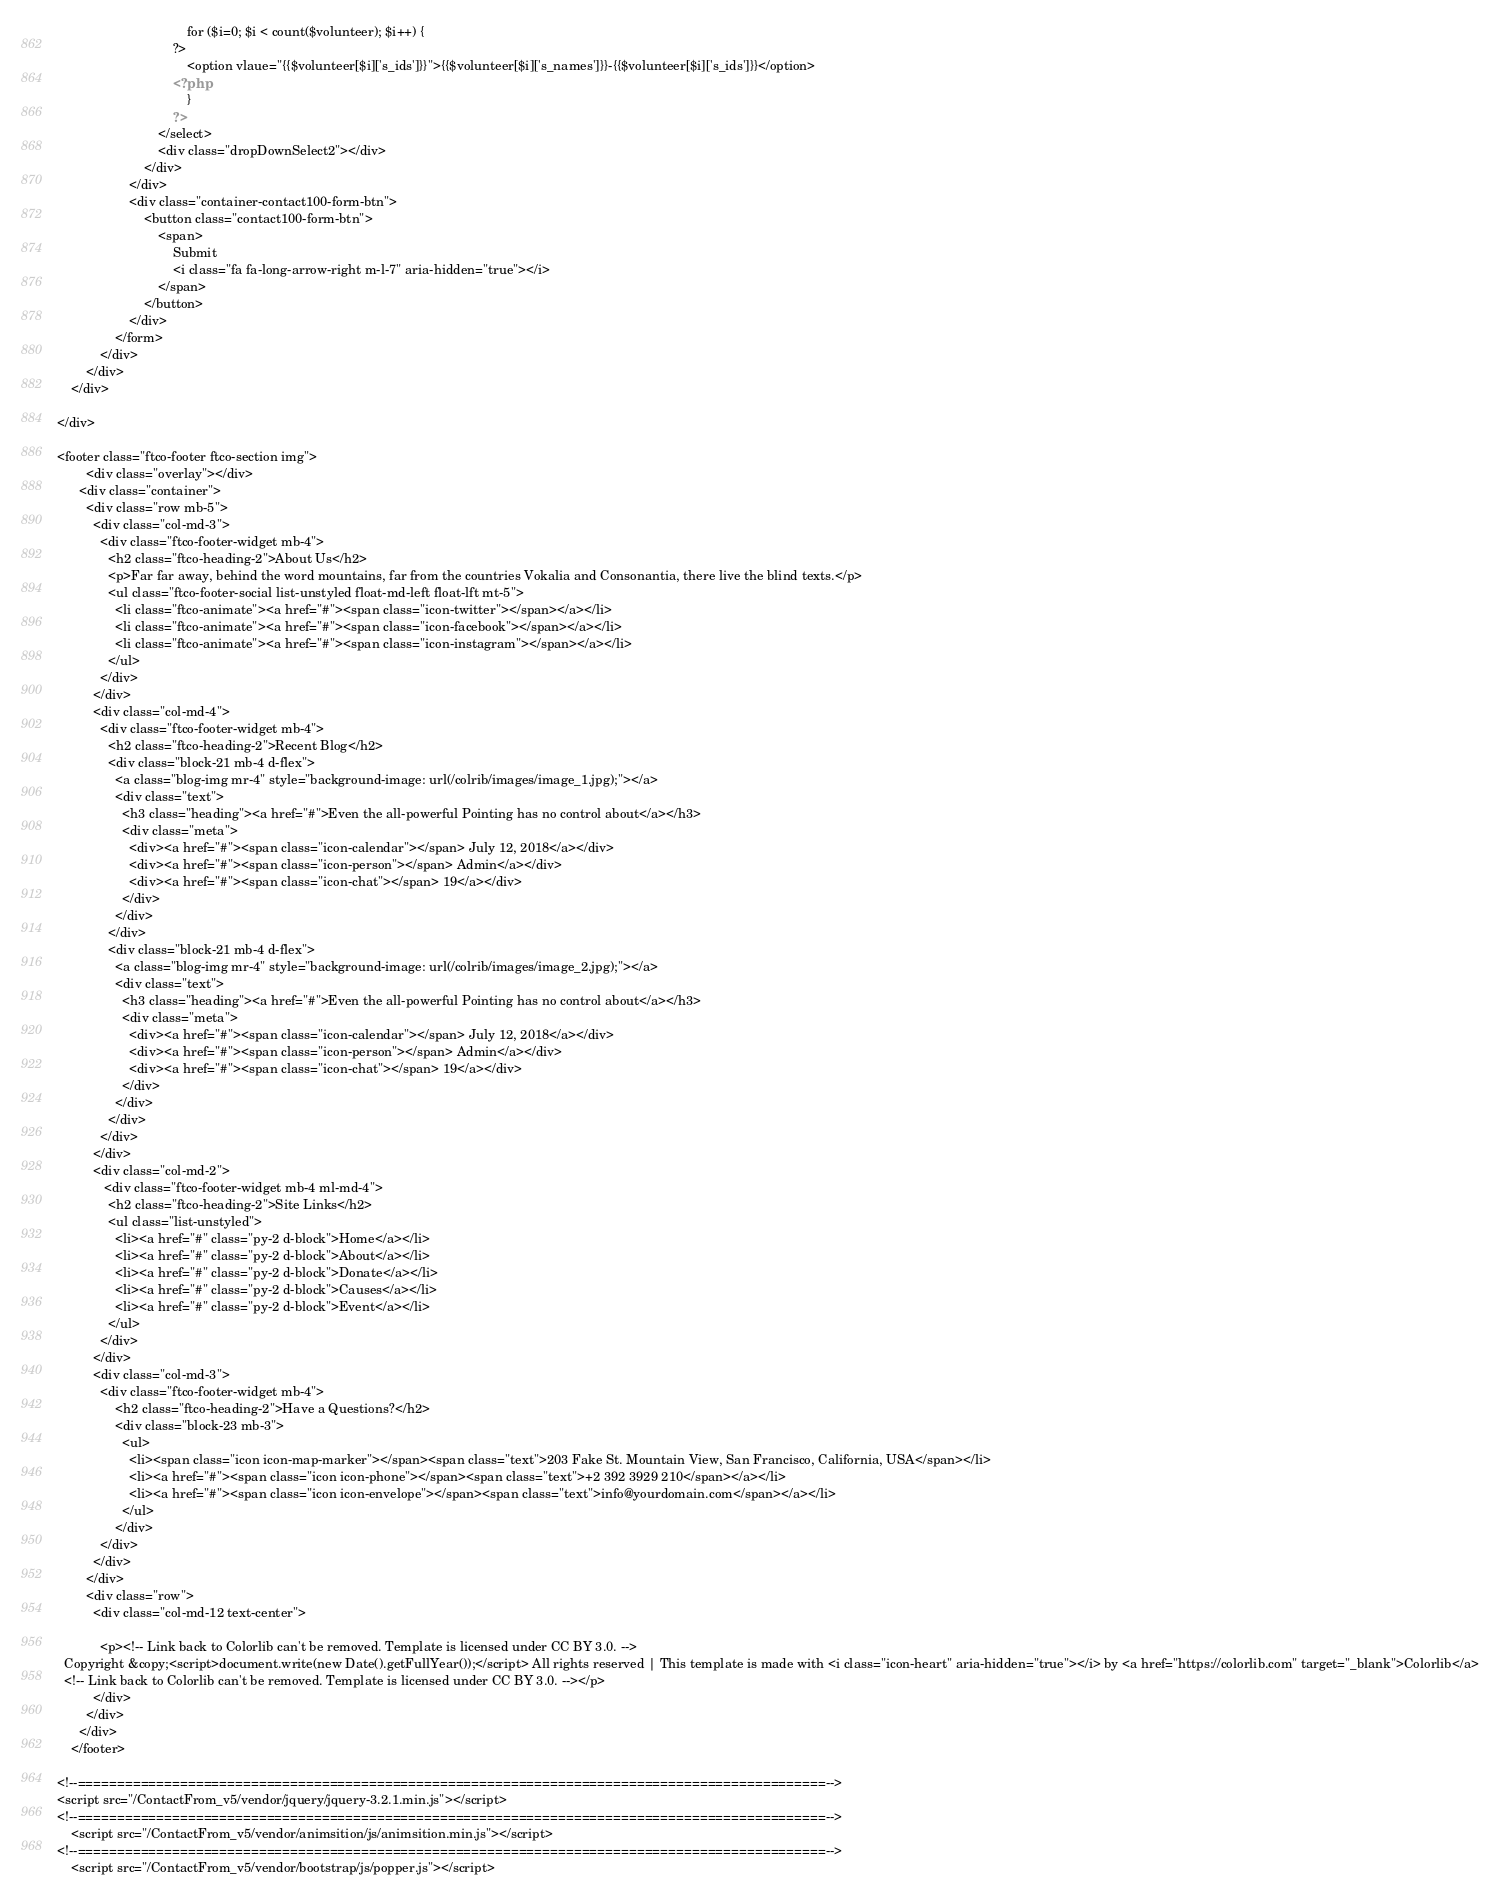<code> <loc_0><loc_0><loc_500><loc_500><_PHP_>									for ($i=0; $i < count($volunteer); $i++) { 
								?>
									<option vlaue="{{$volunteer[$i]['s_ids']}}">{{$volunteer[$i]['s_names']}}-{{$volunteer[$i]['s_ids']}}</option>
								<?php
									}
								?>
							</select>							
							<div class="dropDownSelect2"></div>
						</div>
					</div>
					<div class="container-contact100-form-btn">
						<button class="contact100-form-btn">
							<span>
								Submit
								<i class="fa fa-long-arrow-right m-l-7" aria-hidden="true"></i>
							</span>
						</button>
					</div>
				</form>
			</div>
		</div>
	</div>
	
</div>

<footer class="ftco-footer ftco-section img">
    	<div class="overlay"></div>
      <div class="container">
        <div class="row mb-5">
          <div class="col-md-3">
            <div class="ftco-footer-widget mb-4">
              <h2 class="ftco-heading-2">About Us</h2>
              <p>Far far away, behind the word mountains, far from the countries Vokalia and Consonantia, there live the blind texts.</p>
              <ul class="ftco-footer-social list-unstyled float-md-left float-lft mt-5">
                <li class="ftco-animate"><a href="#"><span class="icon-twitter"></span></a></li>
                <li class="ftco-animate"><a href="#"><span class="icon-facebook"></span></a></li>
                <li class="ftco-animate"><a href="#"><span class="icon-instagram"></span></a></li>
              </ul>
            </div>
          </div>
          <div class="col-md-4">
            <div class="ftco-footer-widget mb-4">
              <h2 class="ftco-heading-2">Recent Blog</h2>
              <div class="block-21 mb-4 d-flex">
                <a class="blog-img mr-4" style="background-image: url(/colrib/images/image_1.jpg);"></a>
                <div class="text">
                  <h3 class="heading"><a href="#">Even the all-powerful Pointing has no control about</a></h3>
                  <div class="meta">
                    <div><a href="#"><span class="icon-calendar"></span> July 12, 2018</a></div>
                    <div><a href="#"><span class="icon-person"></span> Admin</a></div>
                    <div><a href="#"><span class="icon-chat"></span> 19</a></div>
                  </div>
                </div>
              </div>
              <div class="block-21 mb-4 d-flex">
                <a class="blog-img mr-4" style="background-image: url(/colrib/images/image_2.jpg);"></a>
                <div class="text">
                  <h3 class="heading"><a href="#">Even the all-powerful Pointing has no control about</a></h3>
                  <div class="meta">
                    <div><a href="#"><span class="icon-calendar"></span> July 12, 2018</a></div>
                    <div><a href="#"><span class="icon-person"></span> Admin</a></div>
                    <div><a href="#"><span class="icon-chat"></span> 19</a></div>
                  </div>
                </div>
              </div>
            </div>
          </div>
          <div class="col-md-2">
             <div class="ftco-footer-widget mb-4 ml-md-4">
              <h2 class="ftco-heading-2">Site Links</h2>
              <ul class="list-unstyled">
                <li><a href="#" class="py-2 d-block">Home</a></li>
                <li><a href="#" class="py-2 d-block">About</a></li>
                <li><a href="#" class="py-2 d-block">Donate</a></li>
                <li><a href="#" class="py-2 d-block">Causes</a></li>
                <li><a href="#" class="py-2 d-block">Event</a></li>
              </ul>
            </div>
          </div>
          <div class="col-md-3">
            <div class="ftco-footer-widget mb-4">
            	<h2 class="ftco-heading-2">Have a Questions?</h2>
            	<div class="block-23 mb-3">
	              <ul>
	                <li><span class="icon icon-map-marker"></span><span class="text">203 Fake St. Mountain View, San Francisco, California, USA</span></li>
	                <li><a href="#"><span class="icon icon-phone"></span><span class="text">+2 392 3929 210</span></a></li>
	                <li><a href="#"><span class="icon icon-envelope"></span><span class="text">info@yourdomain.com</span></a></li>
	              </ul>
	            </div>
            </div>
          </div>
        </div>
        <div class="row">
          <div class="col-md-12 text-center">

            <p><!-- Link back to Colorlib can't be removed. Template is licensed under CC BY 3.0. -->
  Copyright &copy;<script>document.write(new Date().getFullYear());</script> All rights reserved | This template is made with <i class="icon-heart" aria-hidden="true"></i> by <a href="https://colorlib.com" target="_blank">Colorlib</a>
  <!-- Link back to Colorlib can't be removed. Template is licensed under CC BY 3.0. --></p>
          </div>
        </div>
      </div>
    </footer>

<!--===============================================================================================-->
<script src="/ContactFrom_v5/vendor/jquery/jquery-3.2.1.min.js"></script>
<!--===============================================================================================-->
	<script src="/ContactFrom_v5/vendor/animsition/js/animsition.min.js"></script>
<!--===============================================================================================-->
	<script src="/ContactFrom_v5/vendor/bootstrap/js/popper.js"></script></code> 